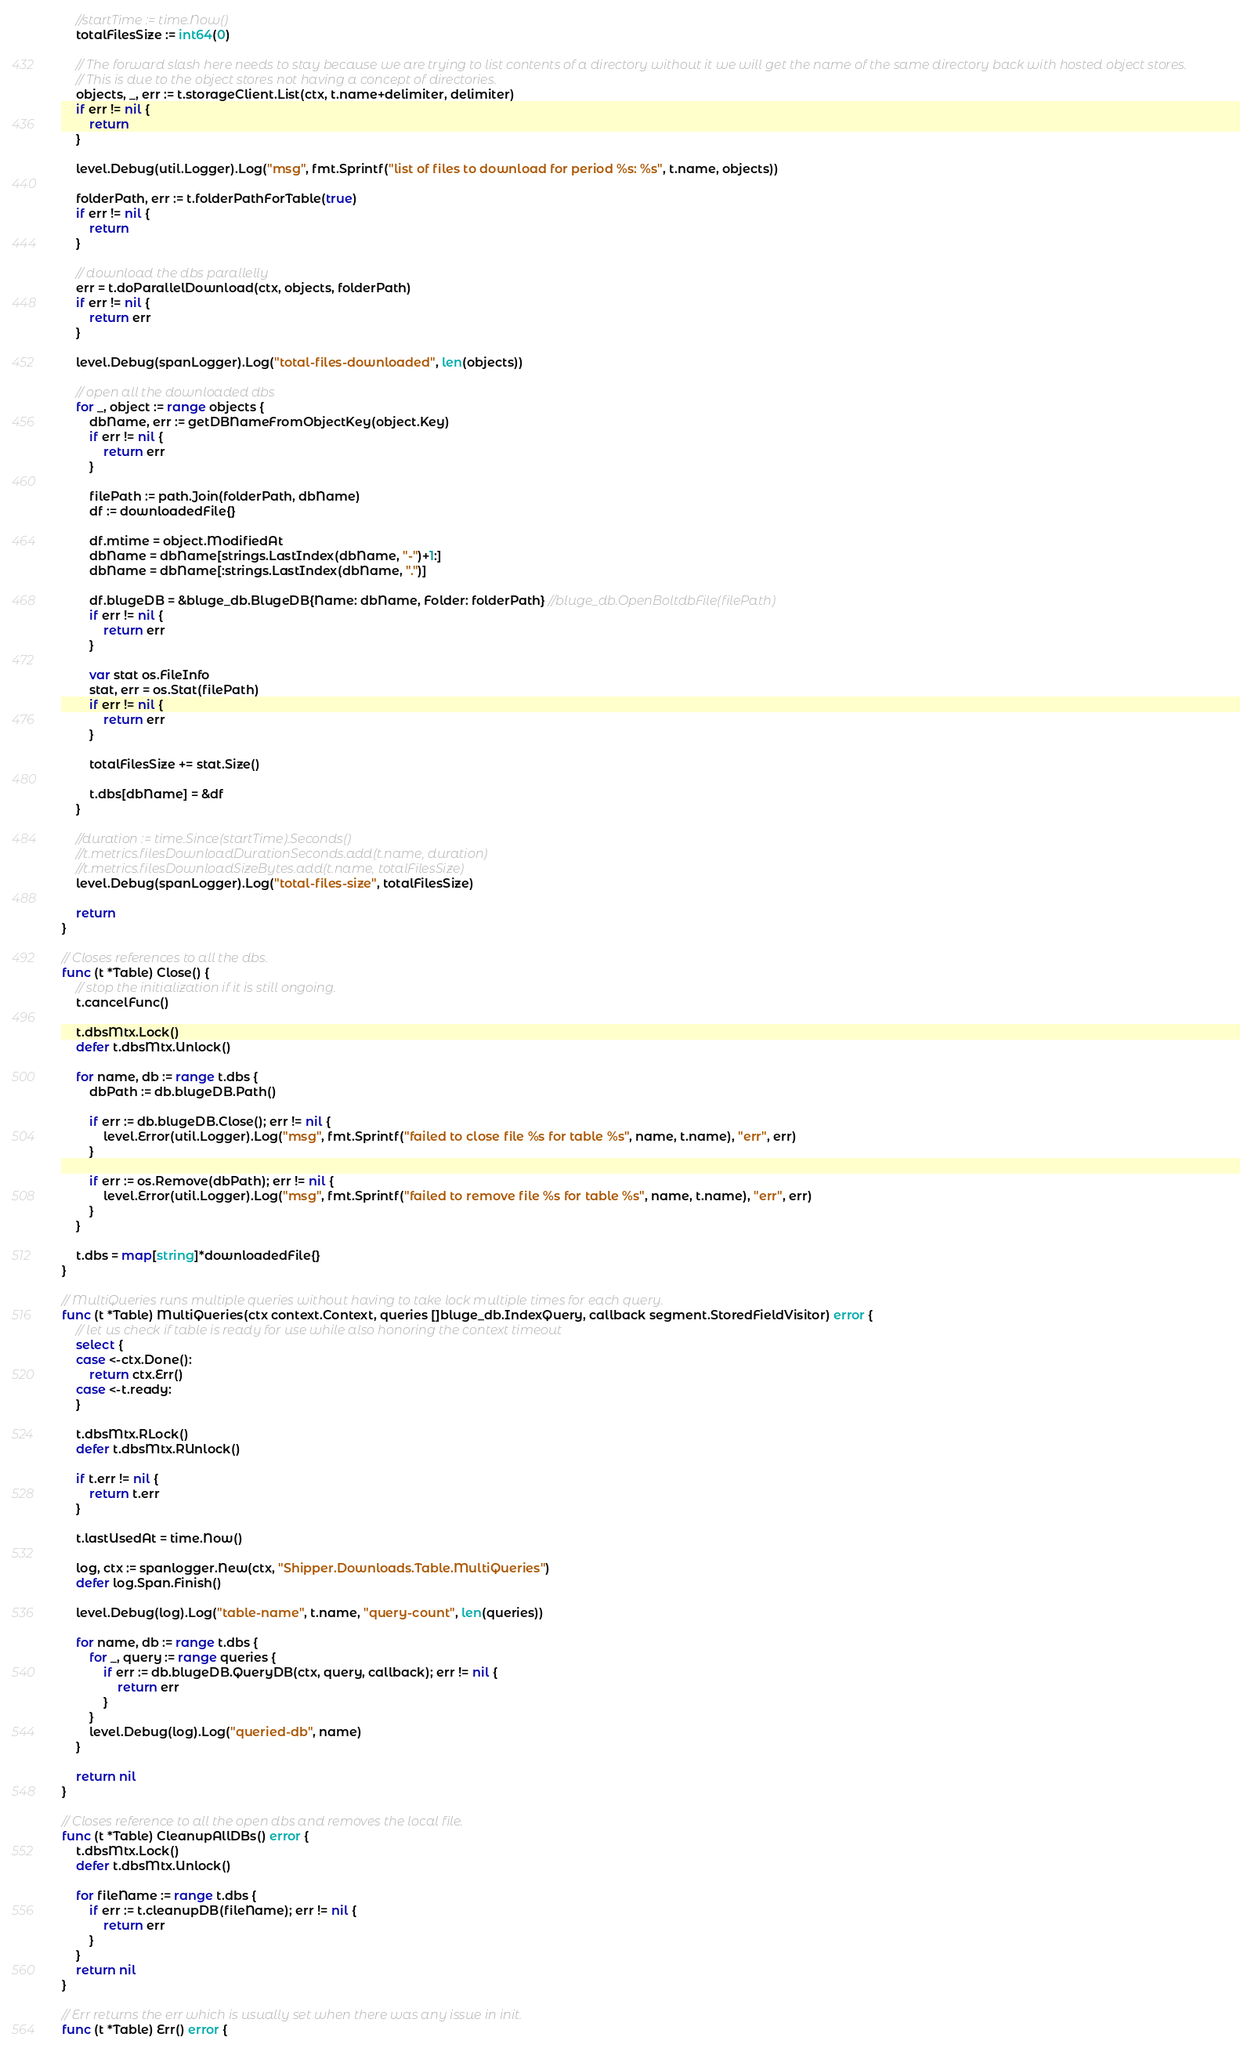<code> <loc_0><loc_0><loc_500><loc_500><_Go_>	//startTime := time.Now()
	totalFilesSize := int64(0)

	// The forward slash here needs to stay because we are trying to list contents of a directory without it we will get the name of the same directory back with hosted object stores.
	// This is due to the object stores not having a concept of directories.
	objects, _, err := t.storageClient.List(ctx, t.name+delimiter, delimiter)
	if err != nil {
		return
	}

	level.Debug(util.Logger).Log("msg", fmt.Sprintf("list of files to download for period %s: %s", t.name, objects))

	folderPath, err := t.folderPathForTable(true)
	if err != nil {
		return
	}

	// download the dbs parallelly
	err = t.doParallelDownload(ctx, objects, folderPath)
	if err != nil {
		return err
	}

	level.Debug(spanLogger).Log("total-files-downloaded", len(objects))

	// open all the downloaded dbs
	for _, object := range objects {
		dbName, err := getDBNameFromObjectKey(object.Key)
		if err != nil {
			return err
		}

		filePath := path.Join(folderPath, dbName)
		df := downloadedFile{}

		df.mtime = object.ModifiedAt
		dbName = dbName[strings.LastIndex(dbName, "-")+1:]
		dbName = dbName[:strings.LastIndex(dbName, ".")]

		df.blugeDB = &bluge_db.BlugeDB{Name: dbName, Folder: folderPath} //bluge_db.OpenBoltdbFile(filePath)
		if err != nil {
			return err
		}

		var stat os.FileInfo
		stat, err = os.Stat(filePath)
		if err != nil {
			return err
		}

		totalFilesSize += stat.Size()

		t.dbs[dbName] = &df
	}

	//duration := time.Since(startTime).Seconds()
	//t.metrics.filesDownloadDurationSeconds.add(t.name, duration)
	//t.metrics.filesDownloadSizeBytes.add(t.name, totalFilesSize)
	level.Debug(spanLogger).Log("total-files-size", totalFilesSize)

	return
}

// Closes references to all the dbs.
func (t *Table) Close() {
	// stop the initialization if it is still ongoing.
	t.cancelFunc()

	t.dbsMtx.Lock()
	defer t.dbsMtx.Unlock()

	for name, db := range t.dbs {
		dbPath := db.blugeDB.Path()

		if err := db.blugeDB.Close(); err != nil {
			level.Error(util.Logger).Log("msg", fmt.Sprintf("failed to close file %s for table %s", name, t.name), "err", err)
		}

		if err := os.Remove(dbPath); err != nil {
			level.Error(util.Logger).Log("msg", fmt.Sprintf("failed to remove file %s for table %s", name, t.name), "err", err)
		}
	}

	t.dbs = map[string]*downloadedFile{}
}

// MultiQueries runs multiple queries without having to take lock multiple times for each query.
func (t *Table) MultiQueries(ctx context.Context, queries []bluge_db.IndexQuery, callback segment.StoredFieldVisitor) error {
	// let us check if table is ready for use while also honoring the context timeout
	select {
	case <-ctx.Done():
		return ctx.Err()
	case <-t.ready:
	}

	t.dbsMtx.RLock()
	defer t.dbsMtx.RUnlock()

	if t.err != nil {
		return t.err
	}

	t.lastUsedAt = time.Now()

	log, ctx := spanlogger.New(ctx, "Shipper.Downloads.Table.MultiQueries")
	defer log.Span.Finish()

	level.Debug(log).Log("table-name", t.name, "query-count", len(queries))

	for name, db := range t.dbs {
		for _, query := range queries {
			if err := db.blugeDB.QueryDB(ctx, query, callback); err != nil {
				return err
			}
		}
		level.Debug(log).Log("queried-db", name)
	}

	return nil
}

// Closes reference to all the open dbs and removes the local file.
func (t *Table) CleanupAllDBs() error {
	t.dbsMtx.Lock()
	defer t.dbsMtx.Unlock()

	for fileName := range t.dbs {
		if err := t.cleanupDB(fileName); err != nil {
			return err
		}
	}
	return nil
}

// Err returns the err which is usually set when there was any issue in init.
func (t *Table) Err() error {</code> 